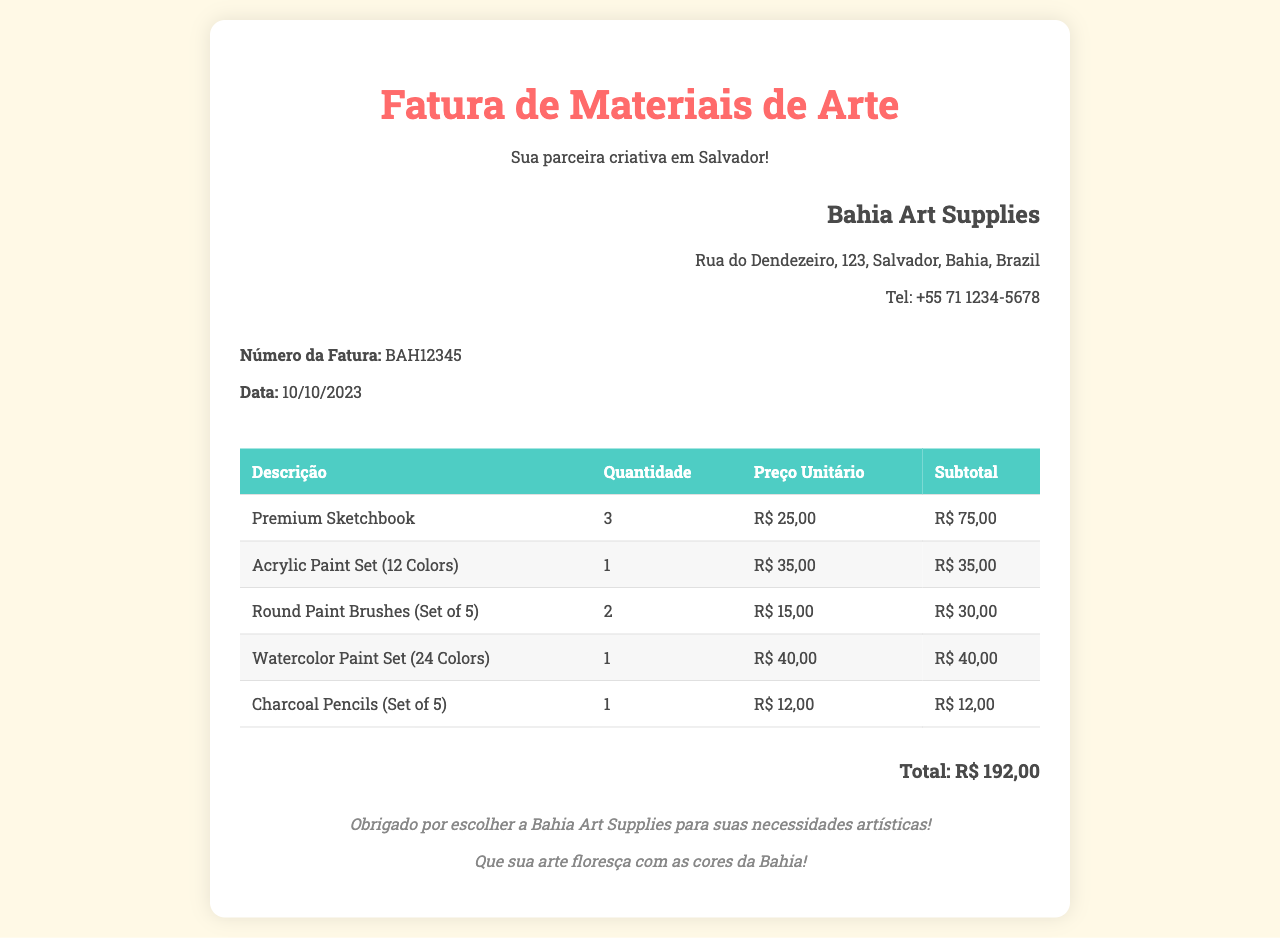What is the invoice number? The invoice number is a specific identifier for the transaction, which is listed at the top of the document.
Answer: BAH12345 What is the date of the invoice? The date indicates when the transaction occurred, and it is prominently displayed in the invoice details.
Answer: 10/10/2023 How many Premium Sketchbooks were purchased? The quantity of each item is listed in the itemized list of products on the invoice.
Answer: 3 What is the subtotal for the Acrylic Paint Set? The subtotal for each item represents its price multiplied by the quantity purchased, shown in the table.
Answer: R$ 35,00 What is the total amount of the invoice? The total is calculated by summing the subtotals of all items on the invoice, and it is shown at the bottom of the document.
Answer: R$ 192,00 Where is the vendor located? The vendor’s address provides information about where they are situated and is found in the vendor information section.
Answer: Rua do Dendezeiro, 123, Salvador, Bahia, Brazil How many types of paint sets are listed in the invoice? This requires counting the different paint sets included in the itemized list, which helps understand the variety of products purchased.
Answer: 2 What are the colors in the Watercolor Paint Set? This asks for specifics about the type of paint set listed in the invoice, but the document does not provide color details.
Answer: 24 Colors Who is the vendor for the art supplies? The name of the vendor is typically listed at the top of the vendor information section of the invoice.
Answer: Bahia Art Supplies What is the footer message about? The footer often contains concluding remarks or gratitude towards the customer, summarizing the vendor's service commitment.
Answer: Obrigado por escolher a Bahia Art Supplies para suas necessidades artísticas! 